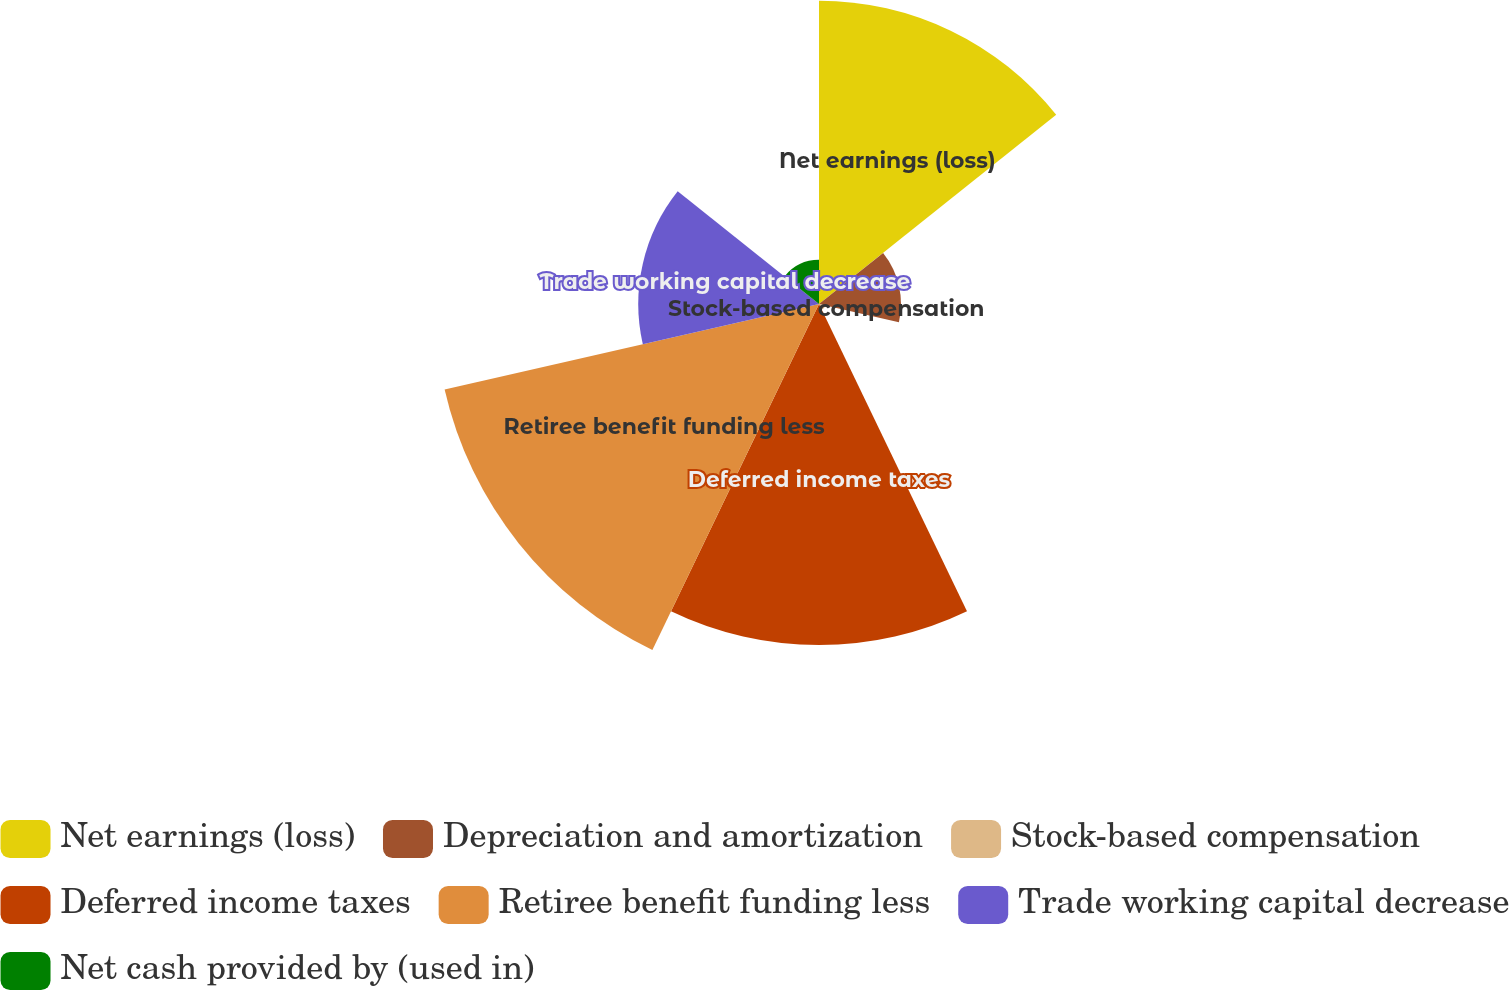<chart> <loc_0><loc_0><loc_500><loc_500><pie_chart><fcel>Net earnings (loss)<fcel>Depreciation and amortization<fcel>Stock-based compensation<fcel>Deferred income taxes<fcel>Retiree benefit funding less<fcel>Trade working capital decrease<fcel>Net cash provided by (used in)<nl><fcel>22.61%<fcel>6.11%<fcel>0.48%<fcel>25.42%<fcel>28.62%<fcel>13.47%<fcel>3.29%<nl></chart> 